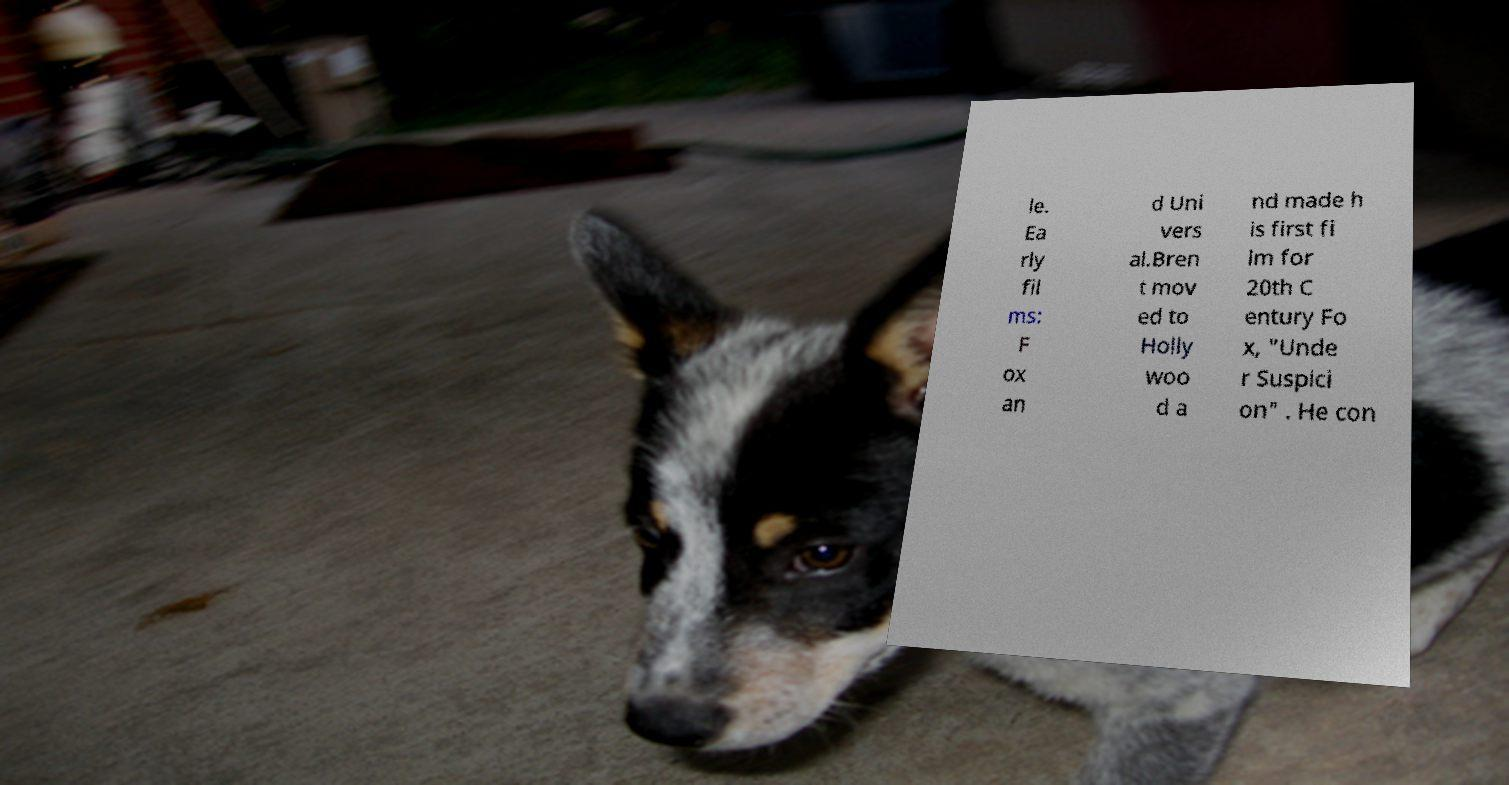For documentation purposes, I need the text within this image transcribed. Could you provide that? le. Ea rly fil ms: F ox an d Uni vers al.Bren t mov ed to Holly woo d a nd made h is first fi lm for 20th C entury Fo x, "Unde r Suspici on" . He con 